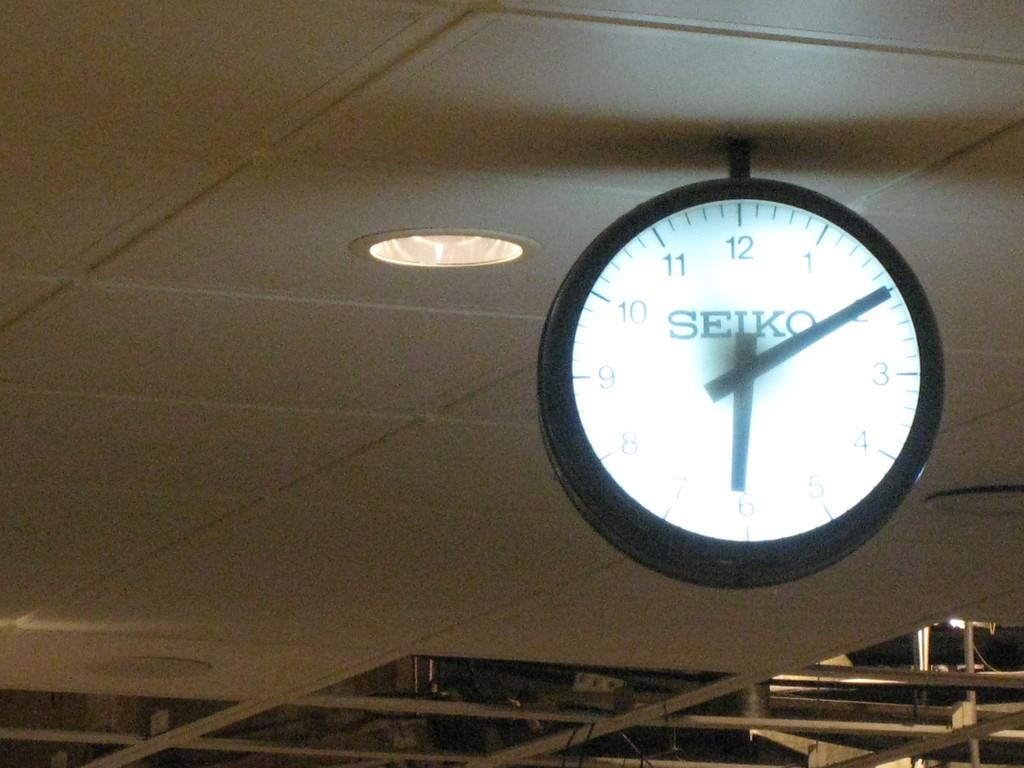Is that clock made by seiko?
Provide a short and direct response. Yes. What number is the small hand pointing to?
Your answer should be very brief. 6. 